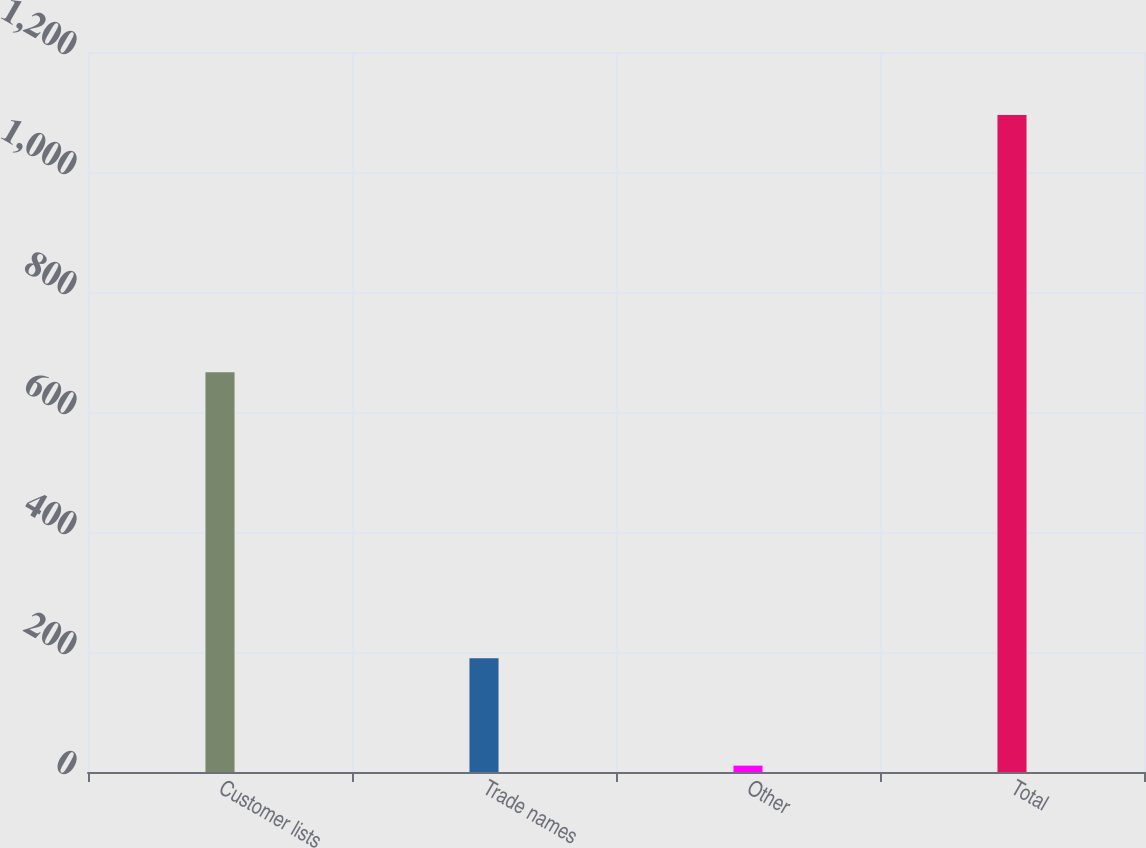<chart> <loc_0><loc_0><loc_500><loc_500><bar_chart><fcel>Customer lists<fcel>Trade names<fcel>Other<fcel>Total<nl><fcel>666.3<fcel>189.4<fcel>10.6<fcel>1094.8<nl></chart> 